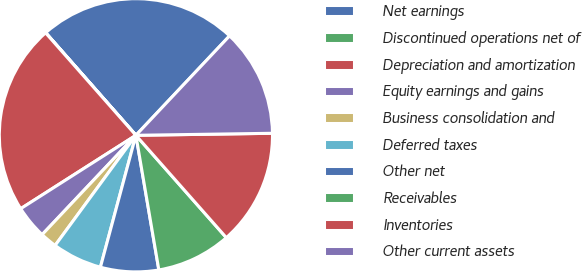Convert chart to OTSL. <chart><loc_0><loc_0><loc_500><loc_500><pie_chart><fcel>Net earnings<fcel>Discontinued operations net of<fcel>Depreciation and amortization<fcel>Equity earnings and gains<fcel>Business consolidation and<fcel>Deferred taxes<fcel>Other net<fcel>Receivables<fcel>Inventories<fcel>Other current assets<nl><fcel>23.51%<fcel>0.02%<fcel>22.53%<fcel>3.93%<fcel>1.97%<fcel>5.89%<fcel>6.87%<fcel>8.83%<fcel>13.72%<fcel>12.74%<nl></chart> 